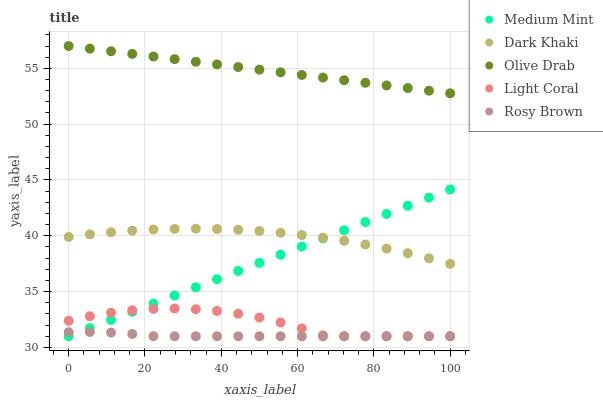Does Rosy Brown have the minimum area under the curve?
Answer yes or no. Yes. Does Olive Drab have the maximum area under the curve?
Answer yes or no. Yes. Does Dark Khaki have the minimum area under the curve?
Answer yes or no. No. Does Dark Khaki have the maximum area under the curve?
Answer yes or no. No. Is Medium Mint the smoothest?
Answer yes or no. Yes. Is Light Coral the roughest?
Answer yes or no. Yes. Is Dark Khaki the smoothest?
Answer yes or no. No. Is Dark Khaki the roughest?
Answer yes or no. No. Does Medium Mint have the lowest value?
Answer yes or no. Yes. Does Dark Khaki have the lowest value?
Answer yes or no. No. Does Olive Drab have the highest value?
Answer yes or no. Yes. Does Dark Khaki have the highest value?
Answer yes or no. No. Is Rosy Brown less than Dark Khaki?
Answer yes or no. Yes. Is Olive Drab greater than Dark Khaki?
Answer yes or no. Yes. Does Medium Mint intersect Rosy Brown?
Answer yes or no. Yes. Is Medium Mint less than Rosy Brown?
Answer yes or no. No. Is Medium Mint greater than Rosy Brown?
Answer yes or no. No. Does Rosy Brown intersect Dark Khaki?
Answer yes or no. No. 